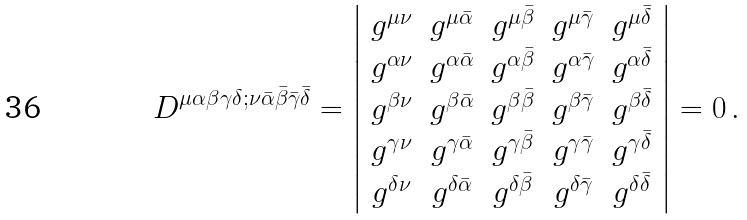<formula> <loc_0><loc_0><loc_500><loc_500>D ^ { \mu \alpha \beta \gamma \delta ; \nu \bar { \alpha } \bar { \beta } \bar { \gamma } \bar { \delta } } = \left | \begin{array} { c c c c c } g ^ { \mu \nu } & g ^ { \mu \bar { \alpha } } & g ^ { \mu \bar { \beta } } & g ^ { \mu \bar { \gamma } } & g ^ { \mu \bar { \delta } } \\ g ^ { \alpha \nu } & g ^ { \alpha \bar { \alpha } } & g ^ { \alpha \bar { \beta } } & g ^ { \alpha \bar { \gamma } } & g ^ { \alpha \bar { \delta } } \\ g ^ { \beta \nu } & g ^ { \beta \bar { \alpha } } & g ^ { \beta \bar { \beta } } & g ^ { \beta \bar { \gamma } } & g ^ { \beta \bar { \delta } } \\ g ^ { \gamma \nu } & g ^ { \gamma \bar { \alpha } } & g ^ { \gamma \bar { \beta } } & g ^ { \gamma \bar { \gamma } } & g ^ { \gamma \bar { \delta } } \\ g ^ { \delta \nu } & g ^ { \delta \bar { \alpha } } & g ^ { \delta \bar { \beta } } & g ^ { \delta \bar { \gamma } } & g ^ { \delta \bar { \delta } } \\ \end{array} \right | = 0 \, .</formula> 